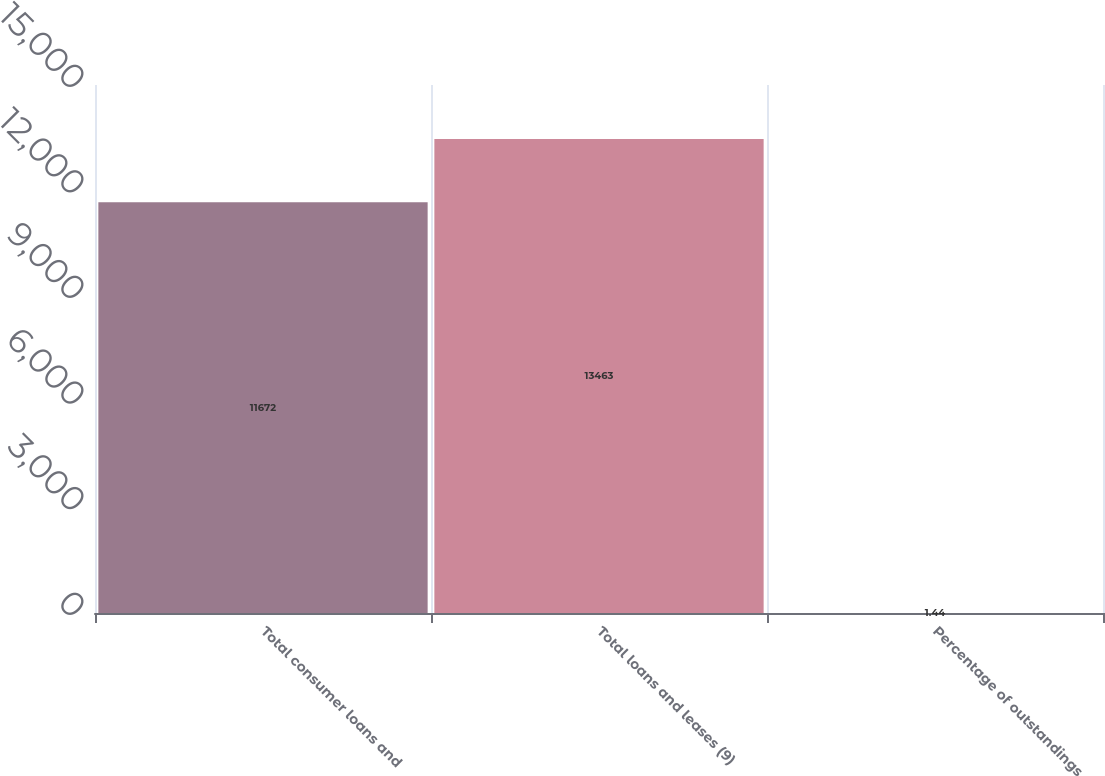Convert chart to OTSL. <chart><loc_0><loc_0><loc_500><loc_500><bar_chart><fcel>Total consumer loans and<fcel>Total loans and leases (9)<fcel>Percentage of outstandings<nl><fcel>11672<fcel>13463<fcel>1.44<nl></chart> 